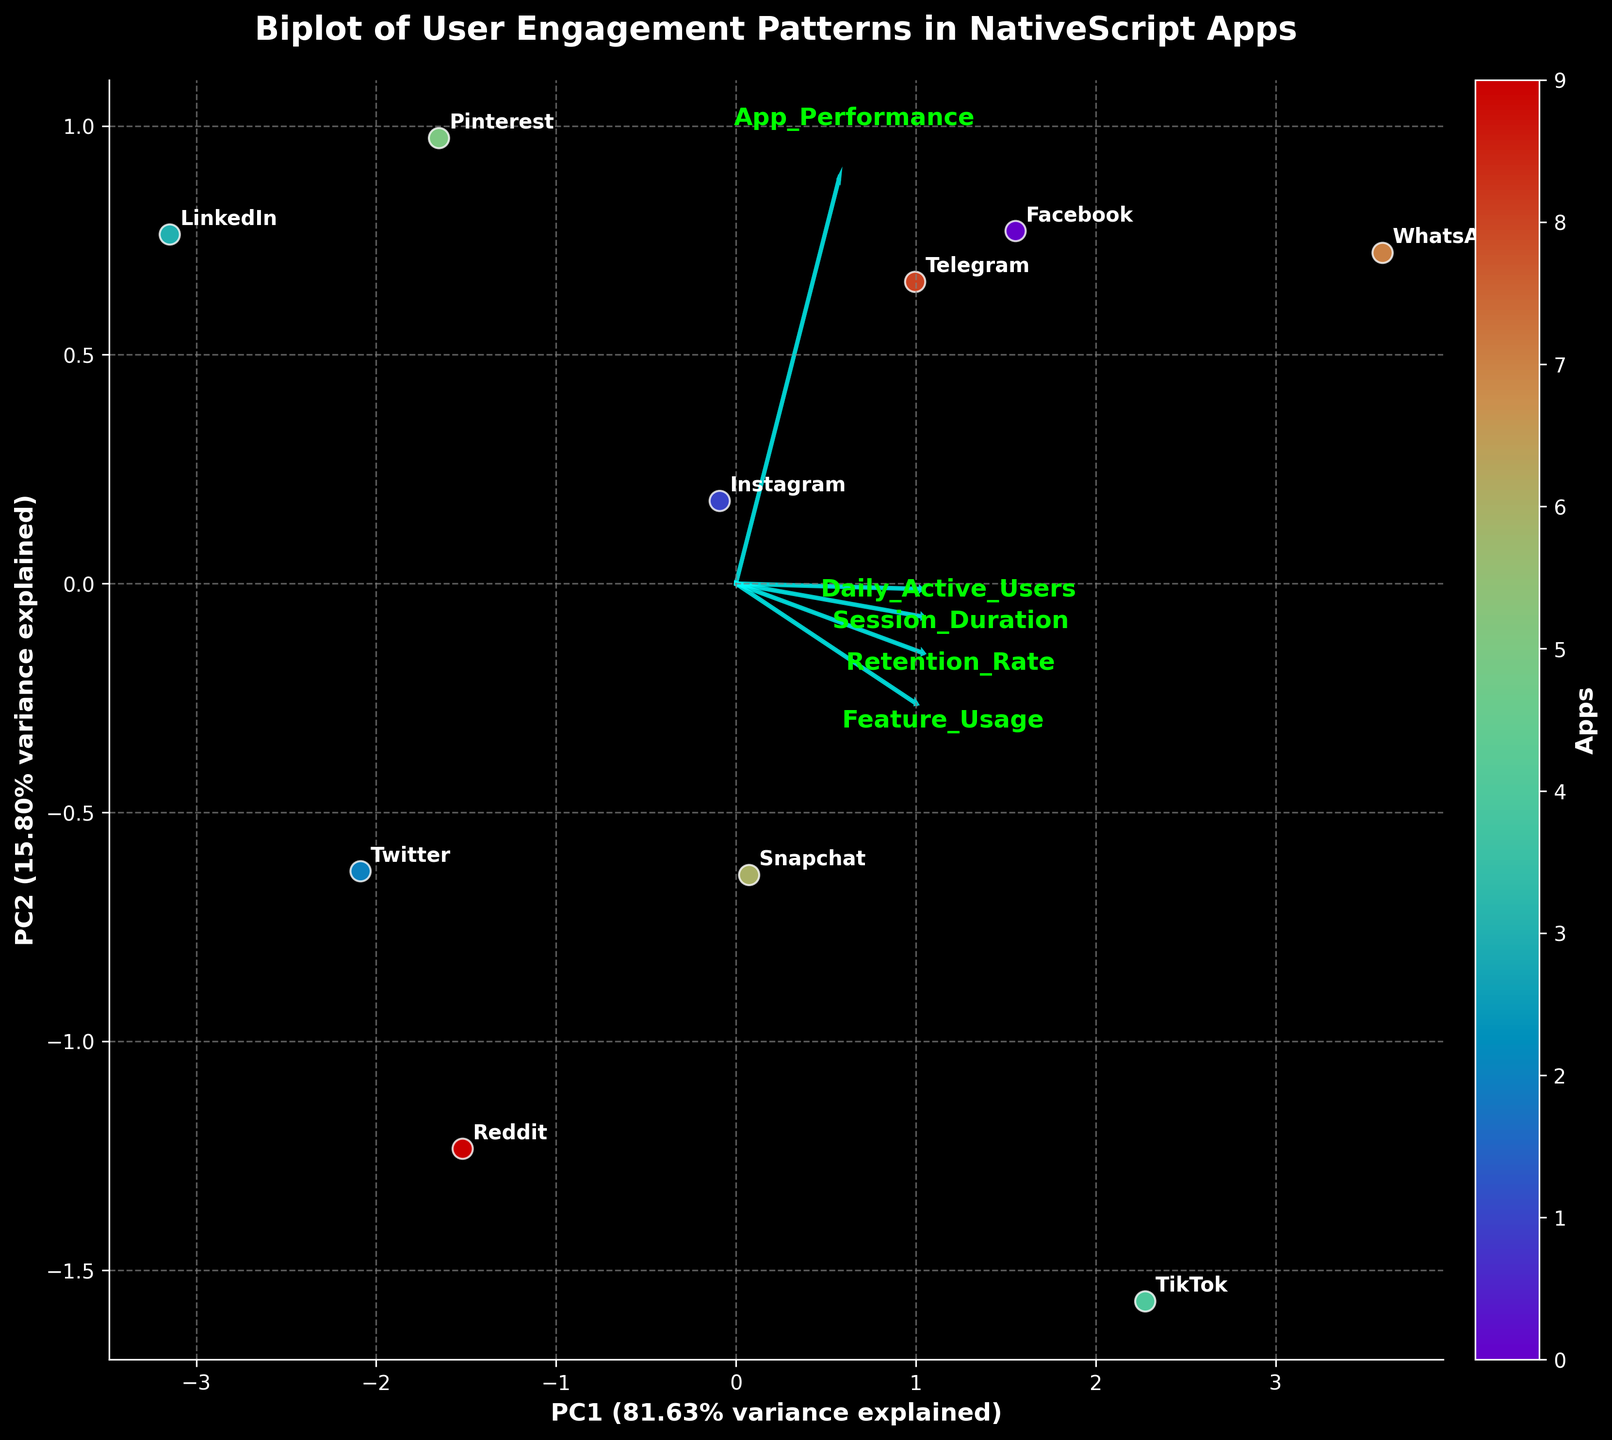How many apps are represented in the biplot? Count each point in the scatter plot. Since each point represents a different app and there are 10 points, there are 10 apps shown.
Answer: 10 What is the title of the figure? Look at the top of the figure for the title. It reads "Biplot of User Engagement Patterns in NativeScript Apps".
Answer: Biplot of User Engagement Patterns in NativeScript Apps Which app has the highest PC1 score? Look at the points on the biplot and identify the one farthest to the right along PC1. The point for WhatsApp is the farthest to the right.
Answer: WhatsApp Which features have the largest positive and negative loadings on PC1? Examine the arrows representing the loadings for each feature. The arrows for "Daily_Active_Users" and "App_Performance" have the largest positive loadings on PC1, while no strong negative loadings for PC1 are apparent among the features.
Answer: Daily_Active_Users, App_Performance Which feature contributes the most to PC2, and is it positively or negatively loaded? Look at the arrows; the one with the longest arrow in the positive or negative direction along PC2 determines the contribution. The "Retention_Rate" feature has a significant positive loading on PC2.
Answer: Retention_Rate, Positively loaded Which two apps are closest to each other in the biplot? Identify the points that are nearest to each other in the 2D space. Instagram and LinkedIn are the closest to each other.
Answer: Instagram, LinkedIn How much of the total variance is explained by PC1 and PC2 combined? Sum the percentages of variance explained by PC1 and PC2. PC1 explains about 67% and PC2 about 23%. Combined, they explain about 90% of the variance.
Answer: 90% Which app has the lowest combination of PC1 and PC2 scores? Identify the point that is closest to the origin or the lowest in both dimensions. Based on the figure, LinkedIn has the lowest combination of PC1 and PC2 scores.
Answer: LinkedIn What is likely the main reason WhatsApp is farthest to the right on the PC1 axis? Look at the arrows and the loadings for each of the features. WhatsApp lies far along the direction where "Daily_Active_Users" and "App_Performance" have strong positive loadings.
Answer: High Daily_Active_Users and App_Performance 